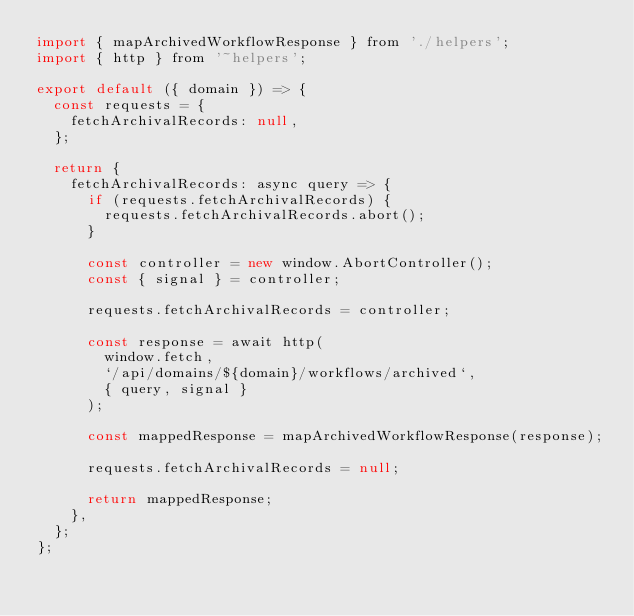<code> <loc_0><loc_0><loc_500><loc_500><_JavaScript_>import { mapArchivedWorkflowResponse } from './helpers';
import { http } from '~helpers';

export default ({ domain }) => {
  const requests = {
    fetchArchivalRecords: null,
  };

  return {
    fetchArchivalRecords: async query => {
      if (requests.fetchArchivalRecords) {
        requests.fetchArchivalRecords.abort();
      }

      const controller = new window.AbortController();
      const { signal } = controller;

      requests.fetchArchivalRecords = controller;

      const response = await http(
        window.fetch,
        `/api/domains/${domain}/workflows/archived`,
        { query, signal }
      );

      const mappedResponse = mapArchivedWorkflowResponse(response);

      requests.fetchArchivalRecords = null;

      return mappedResponse;
    },
  };
};
</code> 